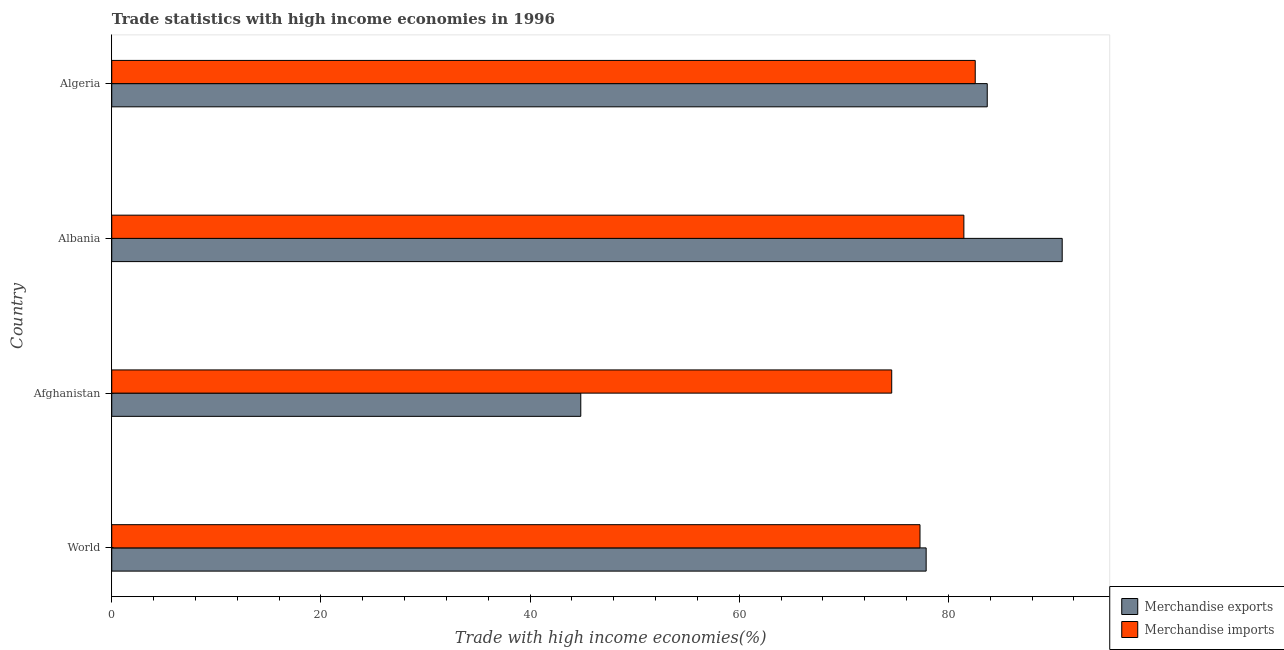How many groups of bars are there?
Your answer should be very brief. 4. Are the number of bars per tick equal to the number of legend labels?
Offer a very short reply. Yes. How many bars are there on the 1st tick from the bottom?
Your response must be concise. 2. What is the label of the 4th group of bars from the top?
Give a very brief answer. World. What is the merchandise exports in Albania?
Offer a terse response. 90.89. Across all countries, what is the maximum merchandise imports?
Ensure brevity in your answer.  82.57. Across all countries, what is the minimum merchandise imports?
Your answer should be very brief. 74.58. In which country was the merchandise imports maximum?
Give a very brief answer. Algeria. In which country was the merchandise exports minimum?
Provide a succinct answer. Afghanistan. What is the total merchandise exports in the graph?
Offer a very short reply. 297.33. What is the difference between the merchandise exports in Algeria and that in World?
Offer a terse response. 5.84. What is the difference between the merchandise exports in Algeria and the merchandise imports in Afghanistan?
Keep it short and to the point. 9.14. What is the average merchandise imports per country?
Your answer should be very brief. 78.98. What is the difference between the merchandise exports and merchandise imports in Albania?
Make the answer very short. 9.4. What is the ratio of the merchandise exports in Albania to that in Algeria?
Ensure brevity in your answer.  1.09. Is the merchandise imports in Afghanistan less than that in Algeria?
Offer a terse response. Yes. Is the difference between the merchandise exports in Algeria and World greater than the difference between the merchandise imports in Algeria and World?
Your answer should be very brief. Yes. What is the difference between the highest and the second highest merchandise imports?
Ensure brevity in your answer.  1.09. What is the difference between the highest and the lowest merchandise imports?
Your answer should be very brief. 7.99. What does the 2nd bar from the top in Algeria represents?
Your answer should be very brief. Merchandise exports. How many bars are there?
Ensure brevity in your answer.  8. Are all the bars in the graph horizontal?
Your answer should be compact. Yes. How many countries are there in the graph?
Keep it short and to the point. 4. What is the difference between two consecutive major ticks on the X-axis?
Provide a succinct answer. 20. Are the values on the major ticks of X-axis written in scientific E-notation?
Offer a terse response. No. Where does the legend appear in the graph?
Ensure brevity in your answer.  Bottom right. How many legend labels are there?
Your answer should be very brief. 2. How are the legend labels stacked?
Your answer should be compact. Vertical. What is the title of the graph?
Offer a very short reply. Trade statistics with high income economies in 1996. Does "Quasi money growth" appear as one of the legend labels in the graph?
Offer a very short reply. No. What is the label or title of the X-axis?
Provide a short and direct response. Trade with high income economies(%). What is the label or title of the Y-axis?
Provide a short and direct response. Country. What is the Trade with high income economies(%) in Merchandise exports in World?
Ensure brevity in your answer.  77.88. What is the Trade with high income economies(%) of Merchandise imports in World?
Provide a short and direct response. 77.29. What is the Trade with high income economies(%) in Merchandise exports in Afghanistan?
Offer a terse response. 44.85. What is the Trade with high income economies(%) in Merchandise imports in Afghanistan?
Ensure brevity in your answer.  74.58. What is the Trade with high income economies(%) in Merchandise exports in Albania?
Provide a succinct answer. 90.89. What is the Trade with high income economies(%) of Merchandise imports in Albania?
Make the answer very short. 81.48. What is the Trade with high income economies(%) of Merchandise exports in Algeria?
Your response must be concise. 83.72. What is the Trade with high income economies(%) in Merchandise imports in Algeria?
Give a very brief answer. 82.57. Across all countries, what is the maximum Trade with high income economies(%) in Merchandise exports?
Offer a terse response. 90.89. Across all countries, what is the maximum Trade with high income economies(%) in Merchandise imports?
Provide a short and direct response. 82.57. Across all countries, what is the minimum Trade with high income economies(%) in Merchandise exports?
Offer a terse response. 44.85. Across all countries, what is the minimum Trade with high income economies(%) of Merchandise imports?
Provide a short and direct response. 74.58. What is the total Trade with high income economies(%) in Merchandise exports in the graph?
Give a very brief answer. 297.33. What is the total Trade with high income economies(%) of Merchandise imports in the graph?
Your response must be concise. 315.92. What is the difference between the Trade with high income economies(%) of Merchandise exports in World and that in Afghanistan?
Ensure brevity in your answer.  33.03. What is the difference between the Trade with high income economies(%) in Merchandise imports in World and that in Afghanistan?
Offer a very short reply. 2.7. What is the difference between the Trade with high income economies(%) in Merchandise exports in World and that in Albania?
Give a very brief answer. -13.01. What is the difference between the Trade with high income economies(%) in Merchandise imports in World and that in Albania?
Make the answer very short. -4.19. What is the difference between the Trade with high income economies(%) of Merchandise exports in World and that in Algeria?
Offer a very short reply. -5.84. What is the difference between the Trade with high income economies(%) of Merchandise imports in World and that in Algeria?
Your answer should be very brief. -5.28. What is the difference between the Trade with high income economies(%) in Merchandise exports in Afghanistan and that in Albania?
Give a very brief answer. -46.04. What is the difference between the Trade with high income economies(%) in Merchandise imports in Afghanistan and that in Albania?
Offer a terse response. -6.9. What is the difference between the Trade with high income economies(%) of Merchandise exports in Afghanistan and that in Algeria?
Make the answer very short. -38.87. What is the difference between the Trade with high income economies(%) of Merchandise imports in Afghanistan and that in Algeria?
Make the answer very short. -7.99. What is the difference between the Trade with high income economies(%) of Merchandise exports in Albania and that in Algeria?
Your answer should be compact. 7.17. What is the difference between the Trade with high income economies(%) of Merchandise imports in Albania and that in Algeria?
Provide a short and direct response. -1.09. What is the difference between the Trade with high income economies(%) in Merchandise exports in World and the Trade with high income economies(%) in Merchandise imports in Afghanistan?
Keep it short and to the point. 3.29. What is the difference between the Trade with high income economies(%) in Merchandise exports in World and the Trade with high income economies(%) in Merchandise imports in Albania?
Provide a succinct answer. -3.61. What is the difference between the Trade with high income economies(%) in Merchandise exports in World and the Trade with high income economies(%) in Merchandise imports in Algeria?
Offer a terse response. -4.69. What is the difference between the Trade with high income economies(%) of Merchandise exports in Afghanistan and the Trade with high income economies(%) of Merchandise imports in Albania?
Your answer should be compact. -36.63. What is the difference between the Trade with high income economies(%) of Merchandise exports in Afghanistan and the Trade with high income economies(%) of Merchandise imports in Algeria?
Provide a short and direct response. -37.72. What is the difference between the Trade with high income economies(%) in Merchandise exports in Albania and the Trade with high income economies(%) in Merchandise imports in Algeria?
Offer a terse response. 8.32. What is the average Trade with high income economies(%) in Merchandise exports per country?
Provide a succinct answer. 74.33. What is the average Trade with high income economies(%) of Merchandise imports per country?
Give a very brief answer. 78.98. What is the difference between the Trade with high income economies(%) in Merchandise exports and Trade with high income economies(%) in Merchandise imports in World?
Make the answer very short. 0.59. What is the difference between the Trade with high income economies(%) of Merchandise exports and Trade with high income economies(%) of Merchandise imports in Afghanistan?
Your response must be concise. -29.73. What is the difference between the Trade with high income economies(%) in Merchandise exports and Trade with high income economies(%) in Merchandise imports in Albania?
Keep it short and to the point. 9.4. What is the difference between the Trade with high income economies(%) of Merchandise exports and Trade with high income economies(%) of Merchandise imports in Algeria?
Offer a very short reply. 1.15. What is the ratio of the Trade with high income economies(%) in Merchandise exports in World to that in Afghanistan?
Provide a short and direct response. 1.74. What is the ratio of the Trade with high income economies(%) in Merchandise imports in World to that in Afghanistan?
Your answer should be very brief. 1.04. What is the ratio of the Trade with high income economies(%) in Merchandise exports in World to that in Albania?
Ensure brevity in your answer.  0.86. What is the ratio of the Trade with high income economies(%) in Merchandise imports in World to that in Albania?
Your response must be concise. 0.95. What is the ratio of the Trade with high income economies(%) of Merchandise exports in World to that in Algeria?
Provide a short and direct response. 0.93. What is the ratio of the Trade with high income economies(%) in Merchandise imports in World to that in Algeria?
Make the answer very short. 0.94. What is the ratio of the Trade with high income economies(%) of Merchandise exports in Afghanistan to that in Albania?
Give a very brief answer. 0.49. What is the ratio of the Trade with high income economies(%) in Merchandise imports in Afghanistan to that in Albania?
Offer a terse response. 0.92. What is the ratio of the Trade with high income economies(%) in Merchandise exports in Afghanistan to that in Algeria?
Keep it short and to the point. 0.54. What is the ratio of the Trade with high income economies(%) in Merchandise imports in Afghanistan to that in Algeria?
Keep it short and to the point. 0.9. What is the ratio of the Trade with high income economies(%) in Merchandise exports in Albania to that in Algeria?
Offer a terse response. 1.09. What is the difference between the highest and the second highest Trade with high income economies(%) in Merchandise exports?
Give a very brief answer. 7.17. What is the difference between the highest and the second highest Trade with high income economies(%) in Merchandise imports?
Provide a succinct answer. 1.09. What is the difference between the highest and the lowest Trade with high income economies(%) in Merchandise exports?
Offer a terse response. 46.04. What is the difference between the highest and the lowest Trade with high income economies(%) in Merchandise imports?
Provide a succinct answer. 7.99. 